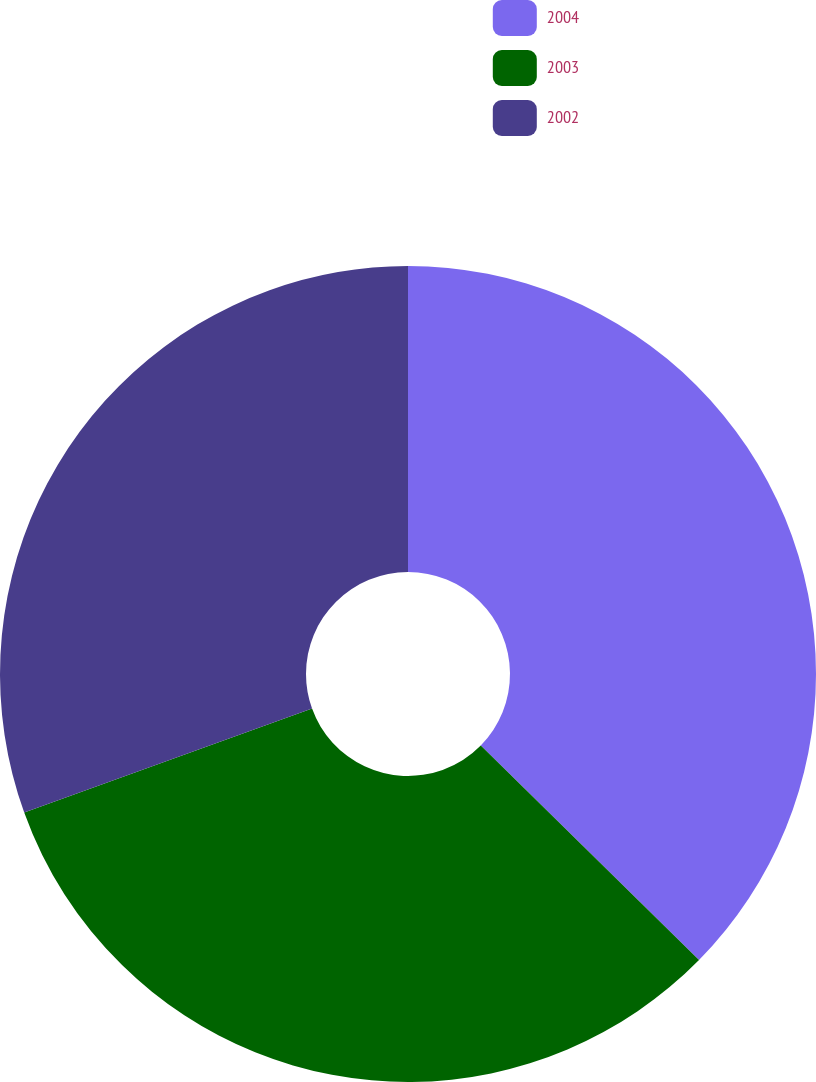Convert chart to OTSL. <chart><loc_0><loc_0><loc_500><loc_500><pie_chart><fcel>2004<fcel>2003<fcel>2002<nl><fcel>37.36%<fcel>32.13%<fcel>30.51%<nl></chart> 